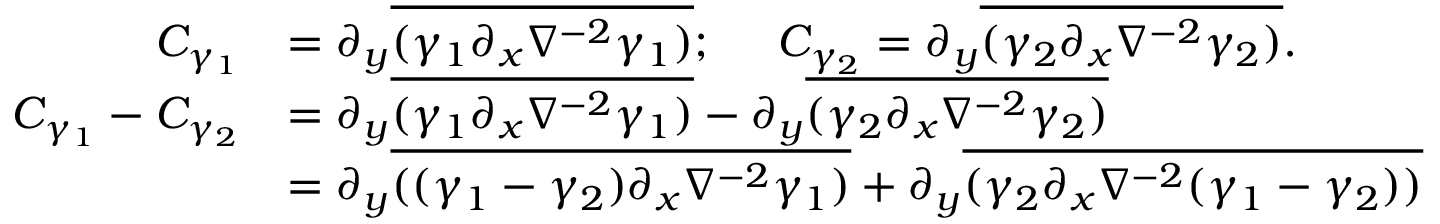<formula> <loc_0><loc_0><loc_500><loc_500>\begin{array} { r l } { C _ { \gamma _ { 1 } } } & { = \partial _ { y } \overline { { ( \gamma _ { 1 } \partial _ { x } \nabla ^ { - 2 } \gamma _ { 1 } ) } } ; \quad C _ { \gamma _ { 2 } } = \partial _ { y } \overline { { ( { \gamma _ { 2 } } \partial _ { x } \nabla ^ { - 2 } { \gamma _ { 2 } } ) } } . } \\ { C _ { \gamma _ { 1 } } - C _ { \gamma _ { 2 } } } & { = \partial _ { y } \overline { { ( \gamma _ { 1 } \partial _ { x } \nabla ^ { - 2 } \gamma _ { 1 } ) } } - \partial _ { y } \overline { { ( { \gamma _ { 2 } } \partial _ { x } \nabla ^ { - 2 } { \gamma _ { 2 } } ) } } } \\ & { = \partial _ { y } \overline { { ( ( \gamma _ { 1 } - { \gamma _ { 2 } } ) \partial _ { x } \nabla ^ { - 2 } \gamma _ { 1 } ) } } + \partial _ { y } \overline { { ( { \gamma _ { 2 } } \partial _ { x } \nabla ^ { - 2 } ( \gamma _ { 1 } - { \gamma _ { 2 } } ) ) } } } \end{array}</formula> 